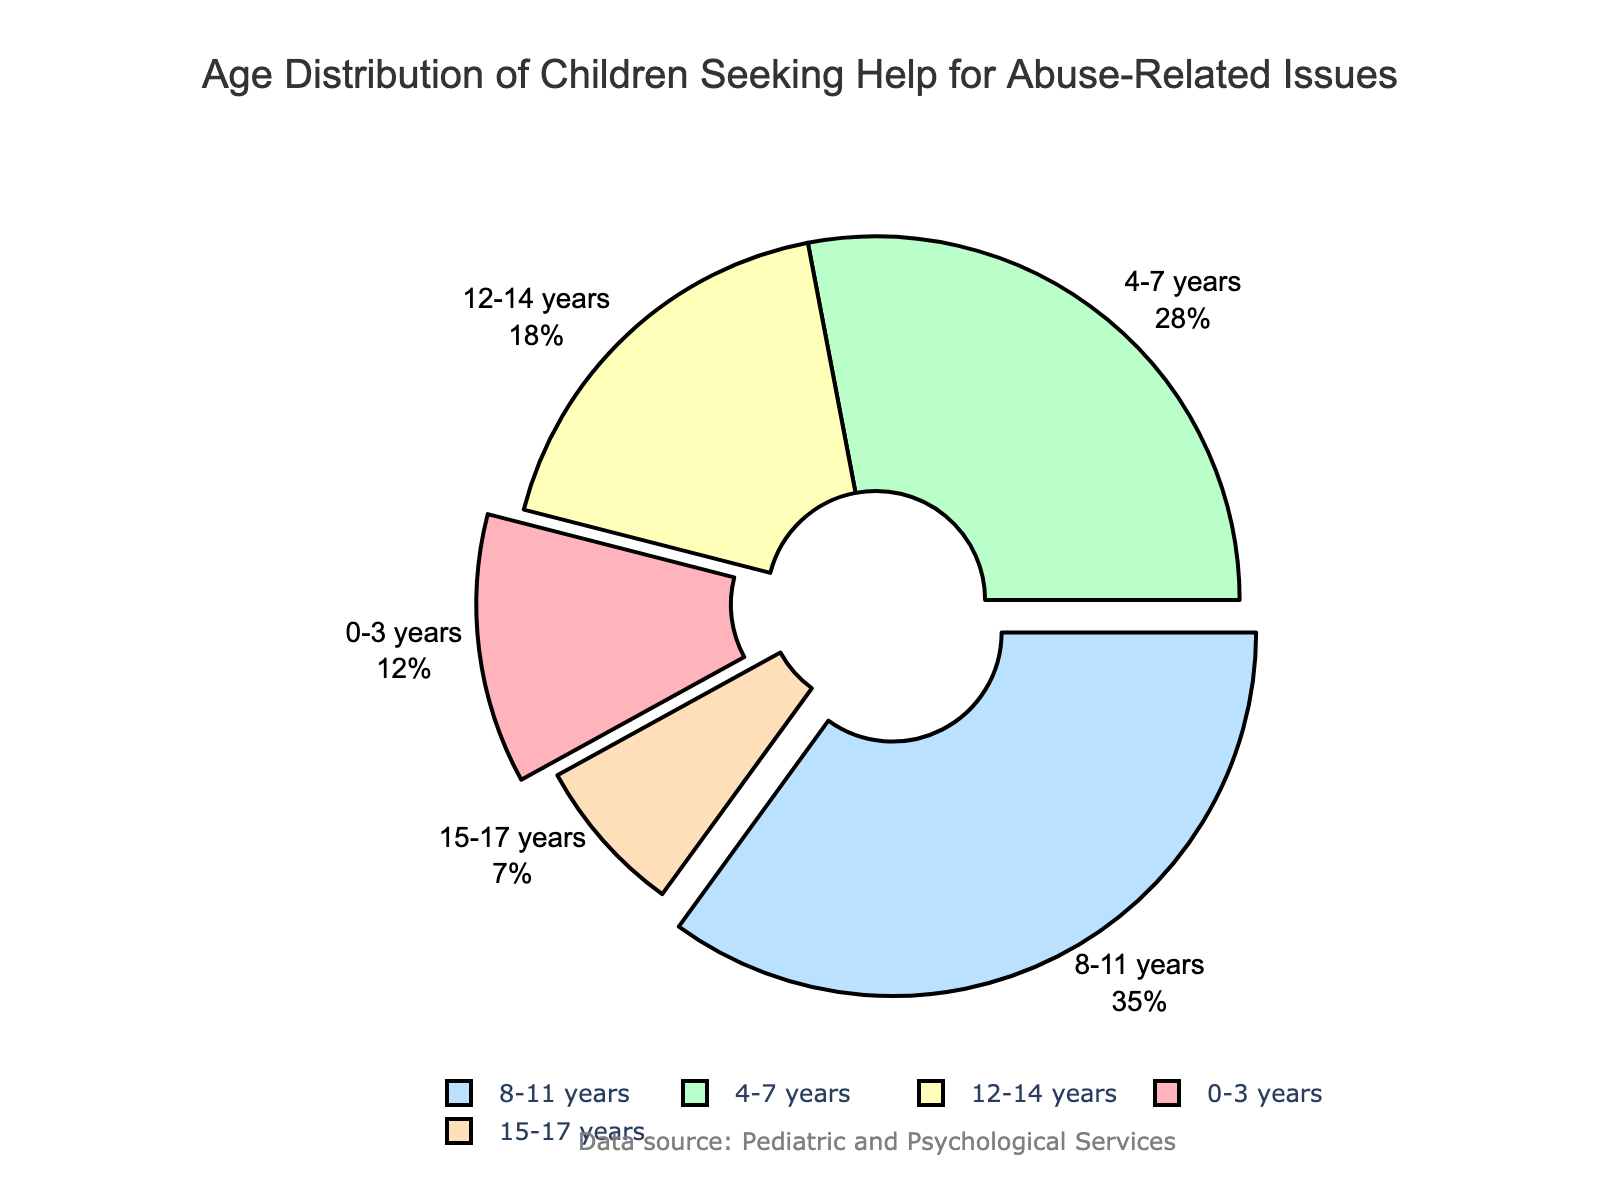What is the age group with the highest percentage of children seeking help? The figure shows a pie chart with percentages for different age groups. Look for the largest segment visually or the highest percentage label.
Answer: 8-11 years Which age group has the smallest representation in the pie chart? By visually assessing the pie chart, identify the smallest segment or the lowest percentage label.
Answer: 15-17 years What is the total percentage of children aged 8-11 years and 4-7 years? Find the percentages for both age groups (35 for 8-11 years and 28 for 4-7 years) and add them together: 35 + 28 = 63
Answer: 63 How does the percentage of the 0-3 years age group compare to the 12-14 years age group? Look at the individual percentages in the pie chart (12% for 0-3 years and 18% for 12-14 years) and compare them. The 12-14 years group is higher: 18 > 12
Answer: 12-14 years is higher What percentage of the children are older than 11 years? Sum the percentages of the 12-14 years (18%) and 15-17 years (7%) age groups: 18 + 7 = 25
Answer: 25 What is the average percentage of children in the 0-3 years, 4-7 years, and 15-17 years groups? Add the percentages for these groups (12, 28, and 7) and divide by the number of groups: (12 + 28 + 7) / 3 = 47 / 3 ≈ 15.67
Answer: 15.67 What is the difference in percentage between the age groups 8-11 years and 15-17 years? Subtract the percentage of the 15-17 years group (7%) from the 8-11 years group (35%): 35 - 7 = 28
Answer: 28 What colors are used to represent the 4-7 years and 0-3 years age groups? Visually identify the colors used in the pie chart for the segments labeled 4-7 years and 0-3 years.
Answer: Green for 4-7 years, Red for 0-3 years Which age group forms exactly 18% of the children seeking help? Locate the segment in the pie chart labeled with 18%, which corresponds to the specific age group.
Answer: 12-14 years Which two age groups are represented by visually "pulled" segments in the pie chart? Examine the pie chart to see which segments are pulled away from the center slightly.
Answer: 0-3 years and 8-11 years 